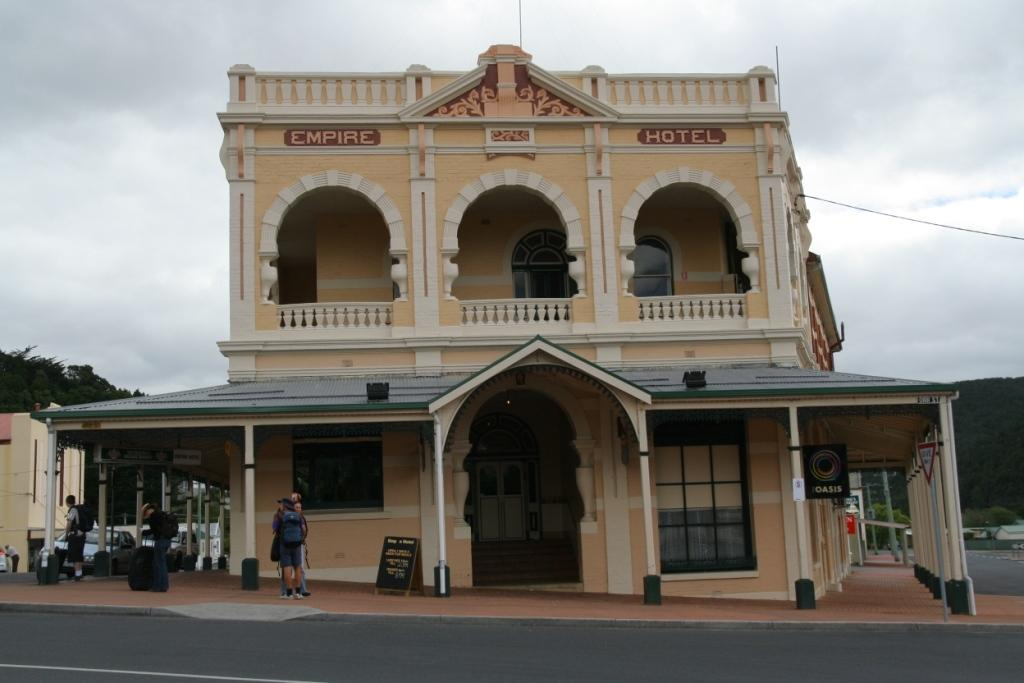What is the main structure in the center of the image? There is a building in the center of the image. What is happening at the bottom of the image? There are persons on the road at the bottom of the image. What can be seen in the background of the image? There are trees and the sky visible in the background of the image. What is the condition of the sky in the image? Clouds are present in the background of the image. How many rings can be seen on the hill in the image? There is no hill or rings present in the image. 